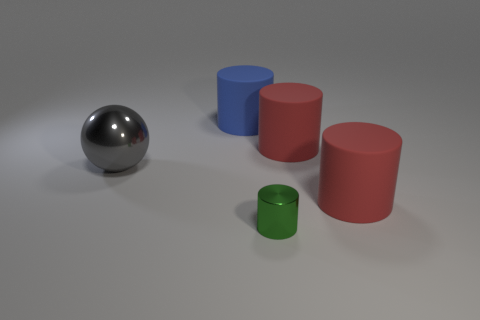Add 2 rubber objects. How many objects exist? 7 Subtract all cylinders. How many objects are left? 1 Add 4 big gray metal cubes. How many big gray metal cubes exist? 4 Subtract 0 yellow spheres. How many objects are left? 5 Subtract all tiny brown matte balls. Subtract all big red cylinders. How many objects are left? 3 Add 5 large gray shiny things. How many large gray shiny things are left? 6 